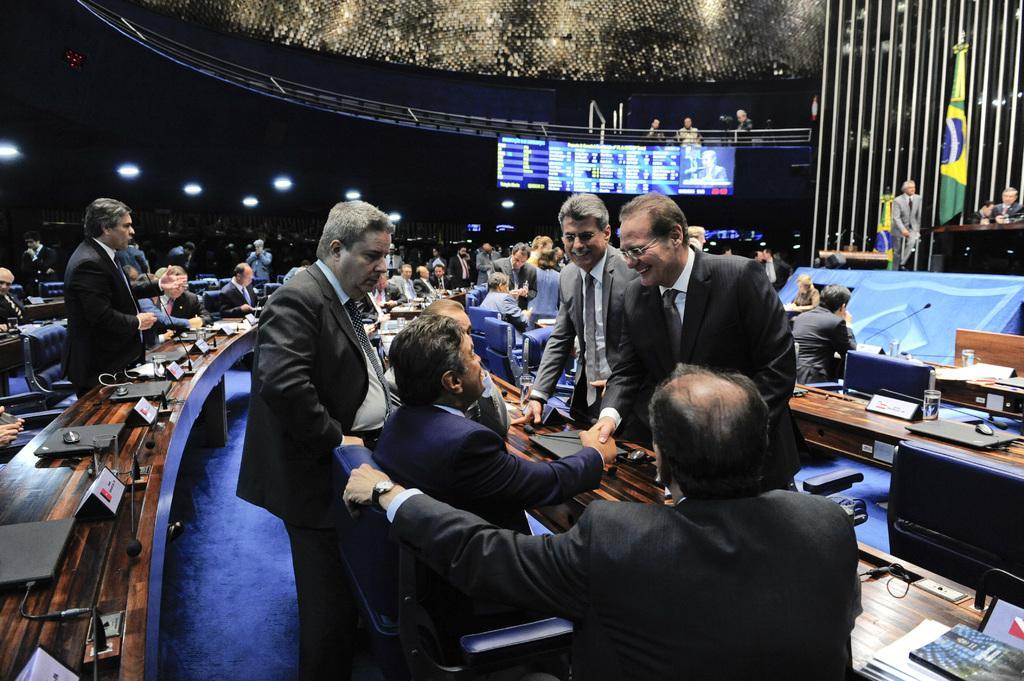Please provide a concise description of this image. Here we can see group of people, chairs, tables, laptops, glasses, mikes, and name boards. There are books on the table. In the background we can see lights, screen, flag, and few persons. 